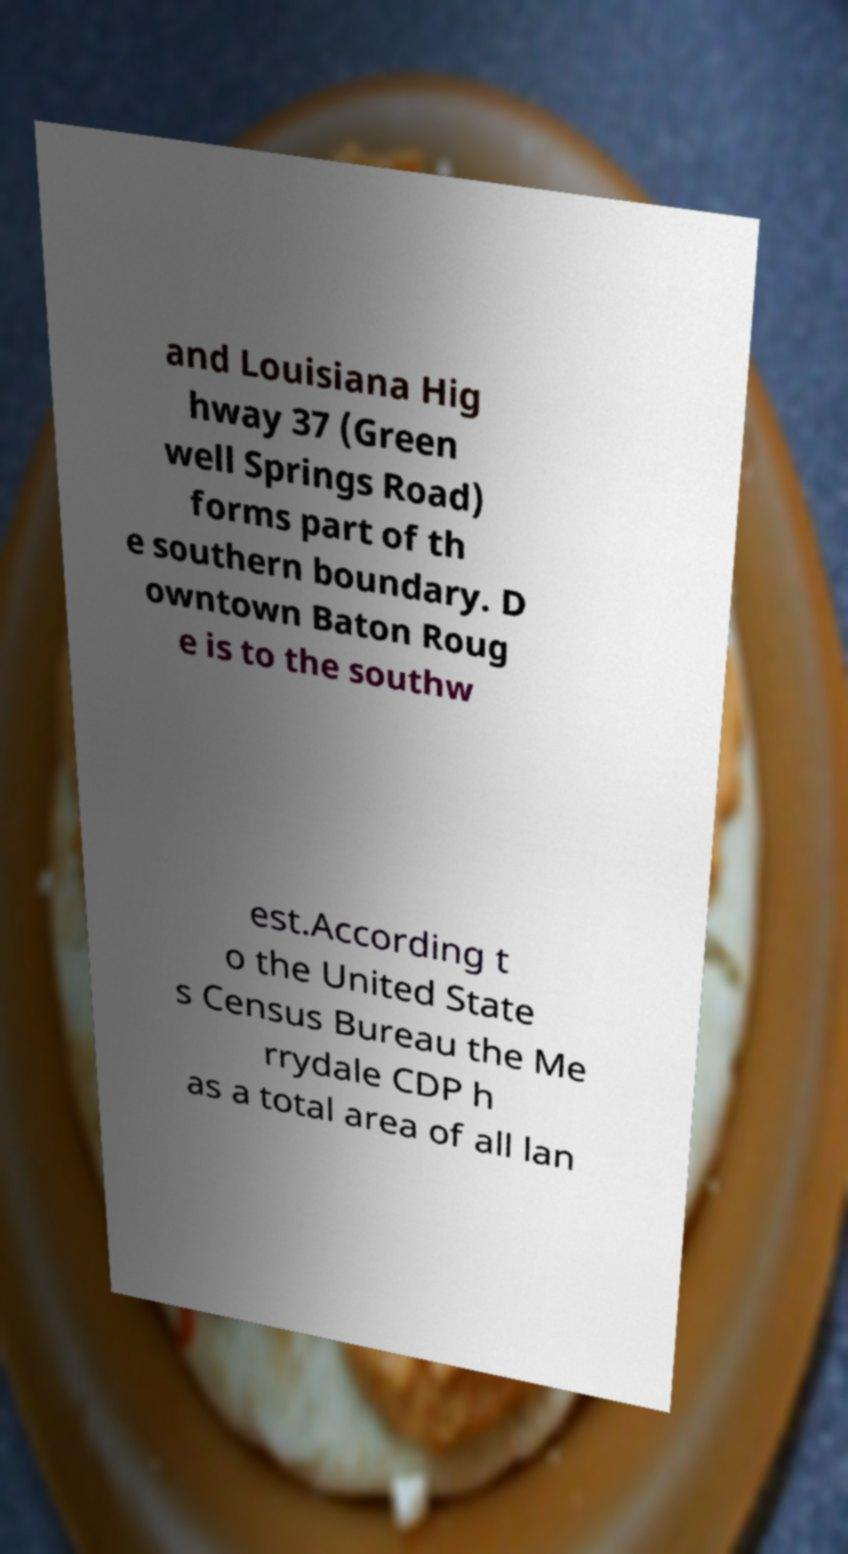I need the written content from this picture converted into text. Can you do that? and Louisiana Hig hway 37 (Green well Springs Road) forms part of th e southern boundary. D owntown Baton Roug e is to the southw est.According t o the United State s Census Bureau the Me rrydale CDP h as a total area of all lan 